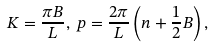<formula> <loc_0><loc_0><loc_500><loc_500>K = \frac { \pi B } { L } , \, p = \frac { 2 \pi } { L } \left ( n + \frac { 1 } { 2 } B \right ) ,</formula> 